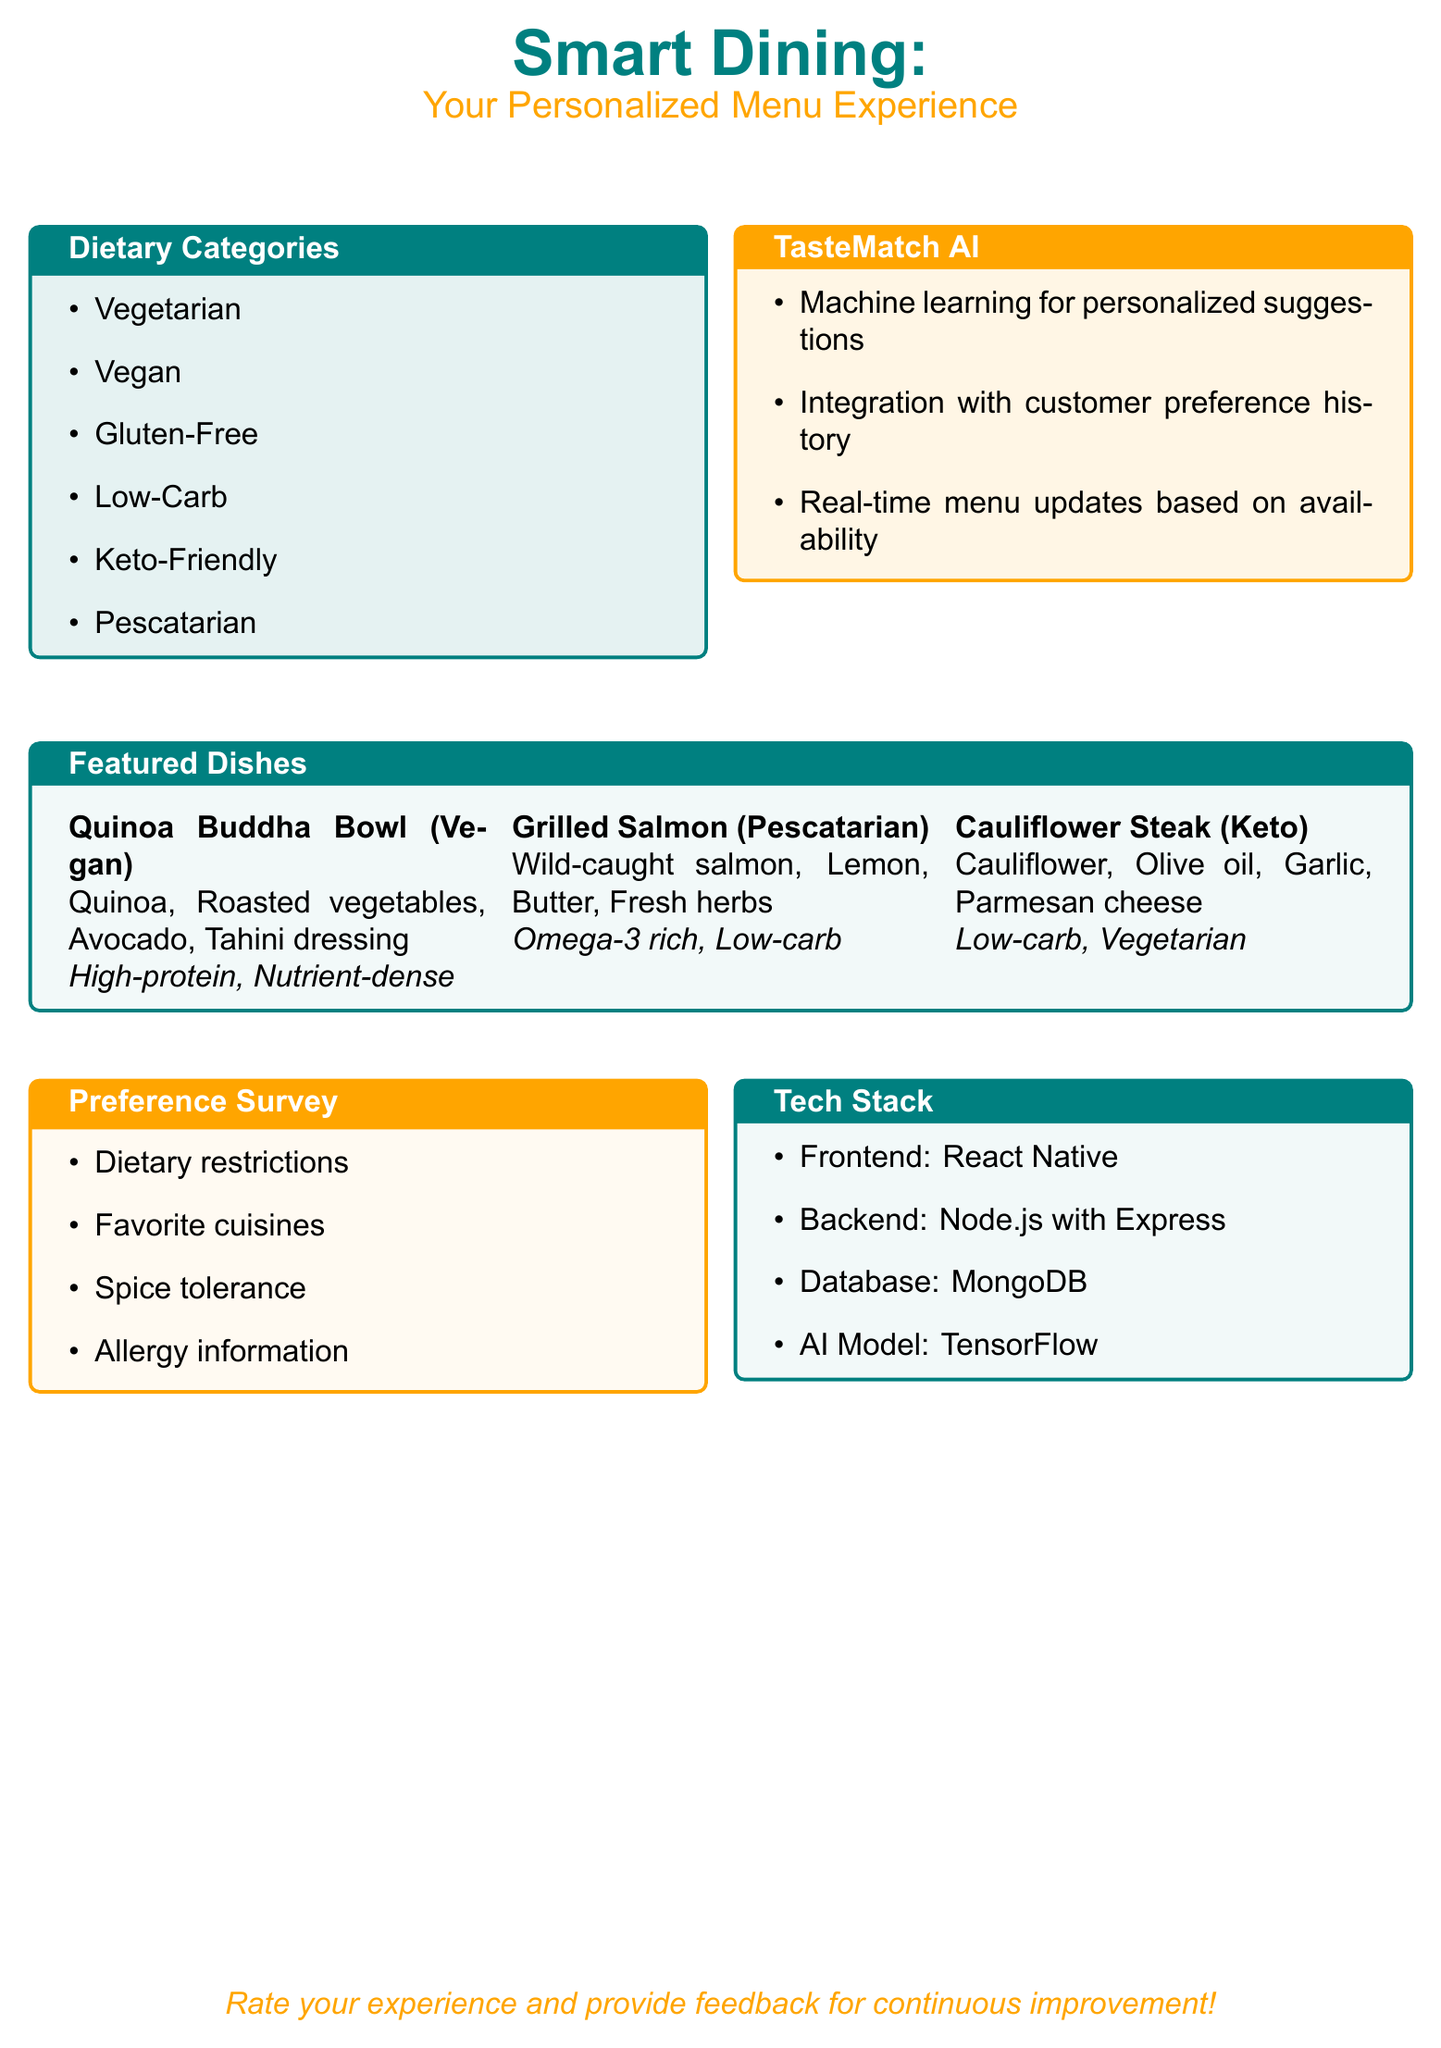What are the dietary categories listed? The dietary categories are outlined in a specific section of the document, mentioning types such as Vegetarian and Vegan.
Answer: Vegetarian, Vegan, Gluten-Free, Low-Carb, Keto-Friendly, Pescatarian What is the first featured dish? The first featured dish mentioned in the document is highlighted under a specific section for featured dishes.
Answer: Quinoa Buddha Bowl What service does TasteMatch AI provide? The document details the functionality provided by the TasteMatch AI, including personalized suggestions.
Answer: Personalized suggestions What is the main protein source in the Grilled Salmon dish? The primary ingredient in Grilled Salmon, a featured dish, is described in the menu.
Answer: Wild-caught salmon Which technology is used for the AI model? The document specifies the technology stack, particularly the AI model utilized.
Answer: TensorFlow What type of cuisine is represented by the Cauliflower Steak? The type of diet category for Cauliflower Steak is specified as part of the highlighted dishes.
Answer: Keto How many items are listed under Dietary Categories? The total items in the Dietary Categories section can be counted based on the information provided.
Answer: Six What type of feedback is encouraged from customers? The document prompts for a specific type of customer engagement regarding experience assessment.
Answer: Rate your experience What is the database technology mentioned? The technology stack includes a particular database technology as specified in the Tech Stack section.
Answer: MongoDB 